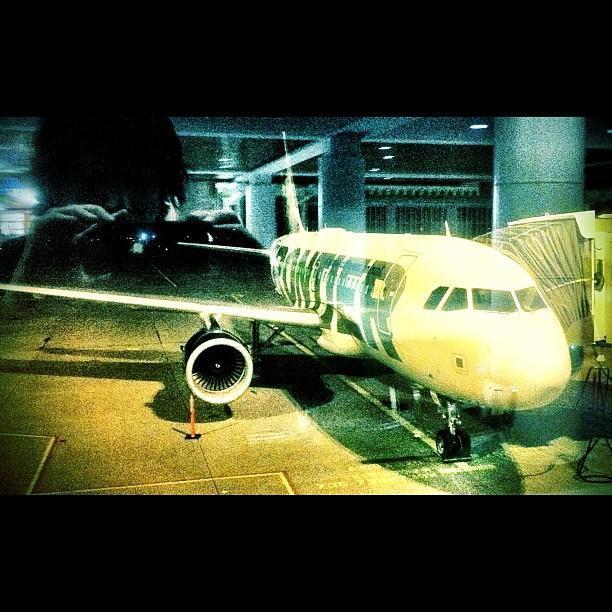How many airplanes can be seen?
Give a very brief answer. 1. How many people are between the two orange buses in the image?
Give a very brief answer. 0. 